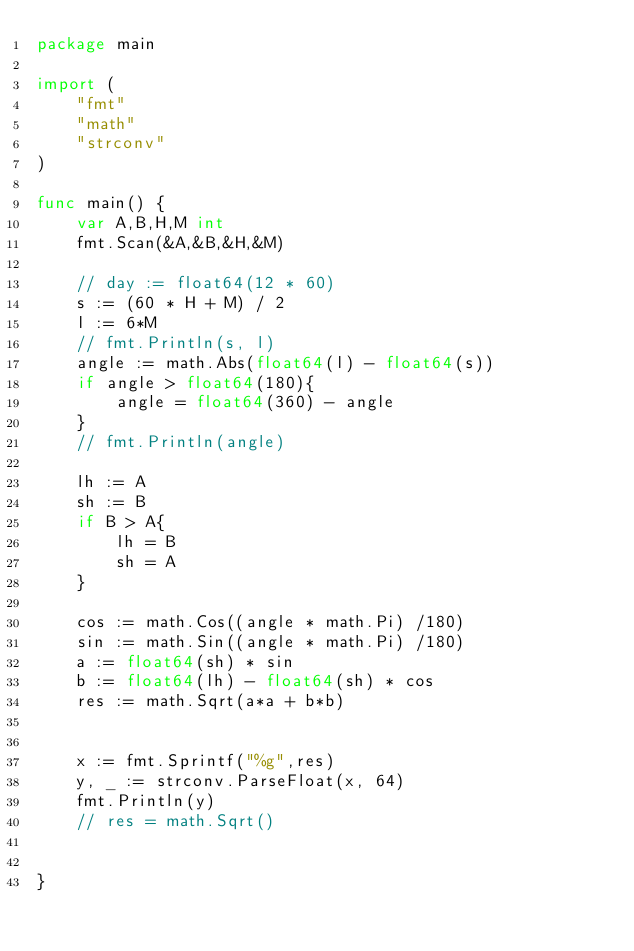<code> <loc_0><loc_0><loc_500><loc_500><_Go_>package main

import (
	"fmt"
	"math"
	"strconv"
)

func main() {
	var A,B,H,M int
	fmt.Scan(&A,&B,&H,&M)

	// day := float64(12 * 60)
	s := (60 * H + M) / 2
	l := 6*M
	// fmt.Println(s, l)
	angle := math.Abs(float64(l) - float64(s))
	if angle > float64(180){
		angle = float64(360) - angle
	}
	// fmt.Println(angle)

	lh := A
	sh := B
	if B > A{
		lh = B
		sh = A
	}

	cos := math.Cos((angle * math.Pi) /180)
	sin := math.Sin((angle * math.Pi) /180)
	a := float64(sh) * sin
	b := float64(lh) - float64(sh) * cos
	res := math.Sqrt(a*a + b*b)

	
	x := fmt.Sprintf("%g",res)
	y, _ := strconv.ParseFloat(x, 64)
	fmt.Println(y)
	// res = math.Sqrt()

	
}
</code> 